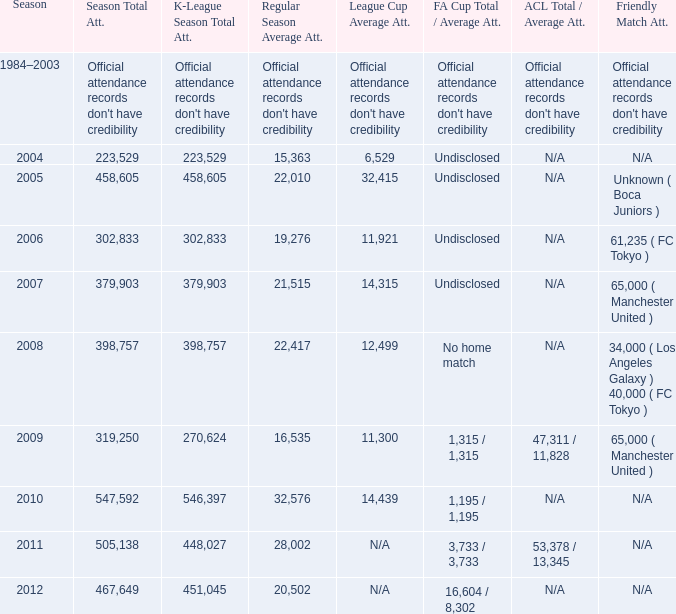What was the overall attendance during the whole season when the mean attendance for league cup was 32,415? 458605.0. 